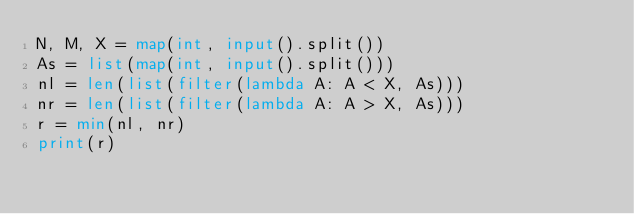<code> <loc_0><loc_0><loc_500><loc_500><_Python_>N, M, X = map(int, input().split())
As = list(map(int, input().split()))
nl = len(list(filter(lambda A: A < X, As)))
nr = len(list(filter(lambda A: A > X, As)))
r = min(nl, nr)
print(r)
</code> 